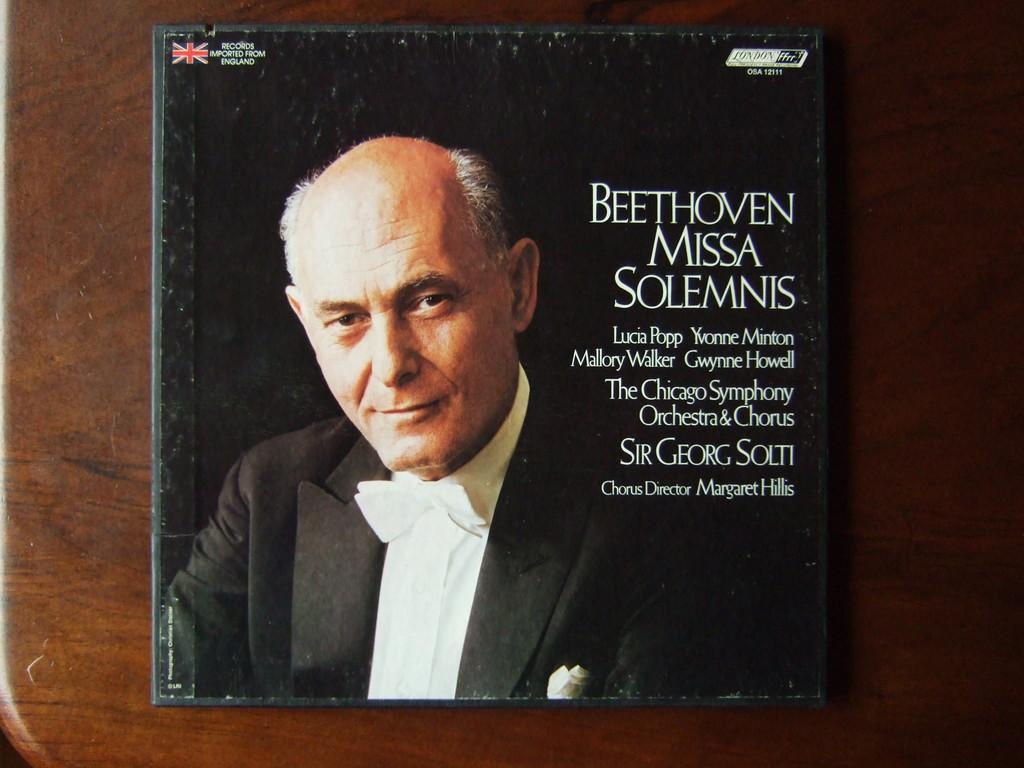Describe this image in one or two sentences. In this image I can see a brown colored surface and on the brown colored surface I can see a black colored object on which I can see a person wearing white shirt and black blazer and I can see few words written on the object. 